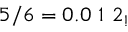Convert formula to latex. <formula><loc_0><loc_0><loc_500><loc_500>5 / 6 = 0 . 0 \ 1 \ 2 _ { ! }</formula> 